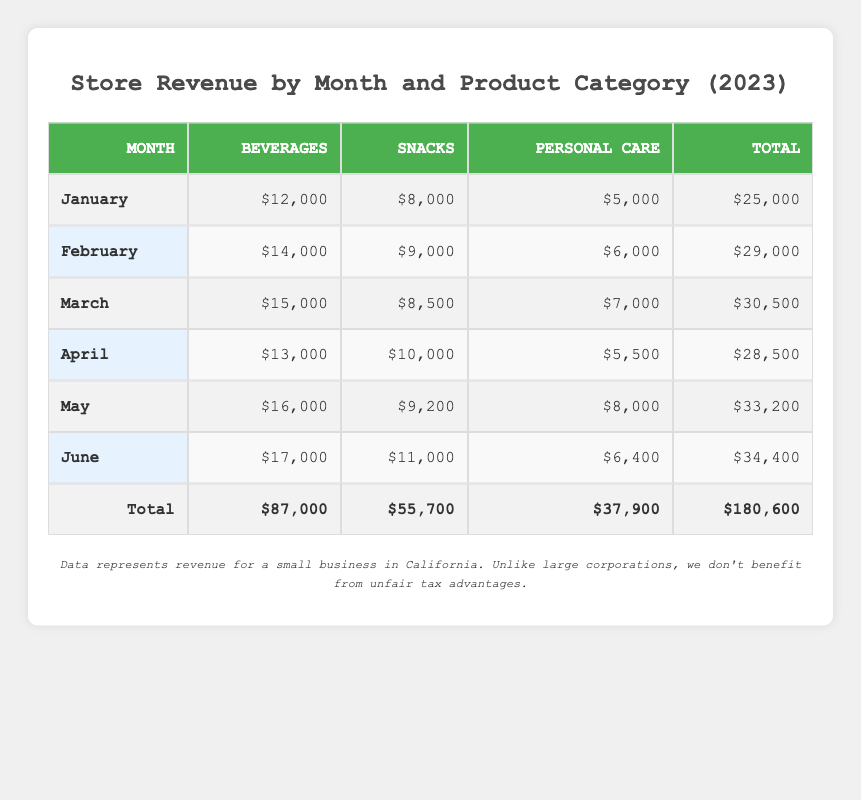What was the total revenue for Beverages in January? The table shows that the revenue for Beverages in January is $12,000.
Answer: $12,000 Which product category had the highest revenue in May? In May, the revenue for each category is: Beverages ($16,000), Snacks ($9,200), and Personal Care ($8,000). The highest revenue is for Beverages.
Answer: Beverages What is the difference between the total revenue of Snacks and Personal Care for the first half of 2023? The total revenue for Snacks from January to June is $55,700 and for Personal Care it's $37,900. The difference is $55,700 - $37,900 = $17,800.
Answer: $17,800 Did the revenue for Personal Care decrease from March to April? The revenue for Personal Care in March is $7,000 and in April it is $5,500. Since $7,000 is greater than $5,500, the revenue did decrease.
Answer: Yes What was the average revenue generated by Beverages from January to June? Summing up the revenues for Beverages gives $12,000 + $14,000 + $15,000 + $13,000 + $16,000 + $17,000 = $87,000 over six months. The average revenue is $87,000 / 6 = $14,500.
Answer: $14,500 Which month had the lowest total revenue? Looking at the total revenues for each month: January ($25,000), February ($29,000), March ($30,500), April ($28,500), May ($33,200), June ($34,400), the lowest total revenue is for January.
Answer: January What is the total revenue from all product categories in June? In June, the total revenue is the sum of Beverages ($17,000), Snacks ($11,000), and Personal Care ($6,400). Adding these, we get $17,000 + $11,000 + $6,400 = $34,400.
Answer: $34,400 Did Snacks ever have higher revenue than Beverages? Looking at the data in the table, Snacks never had a higher revenue than Beverages in any month listed, as Beverages always had higher figures.
Answer: No What is the total revenue from January to June? The total revenue is the sum of all revenues for each month: $25,000 (January) + $29,000 (February) + $30,500 (March) + $28,500 (April) + $33,200 (May) + $34,400 (June) = $180,600.
Answer: $180,600 